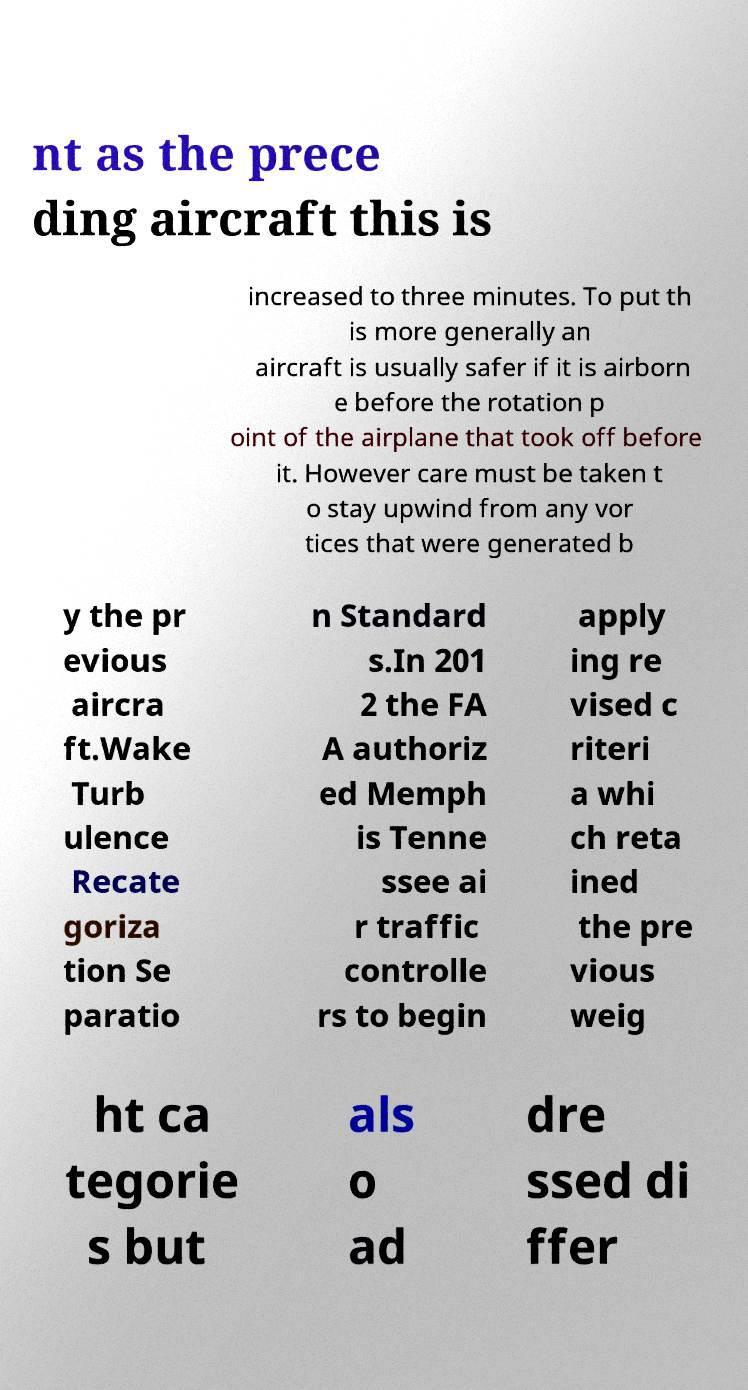I need the written content from this picture converted into text. Can you do that? nt as the prece ding aircraft this is increased to three minutes. To put th is more generally an aircraft is usually safer if it is airborn e before the rotation p oint of the airplane that took off before it. However care must be taken t o stay upwind from any vor tices that were generated b y the pr evious aircra ft.Wake Turb ulence Recate goriza tion Se paratio n Standard s.In 201 2 the FA A authoriz ed Memph is Tenne ssee ai r traffic controlle rs to begin apply ing re vised c riteri a whi ch reta ined the pre vious weig ht ca tegorie s but als o ad dre ssed di ffer 